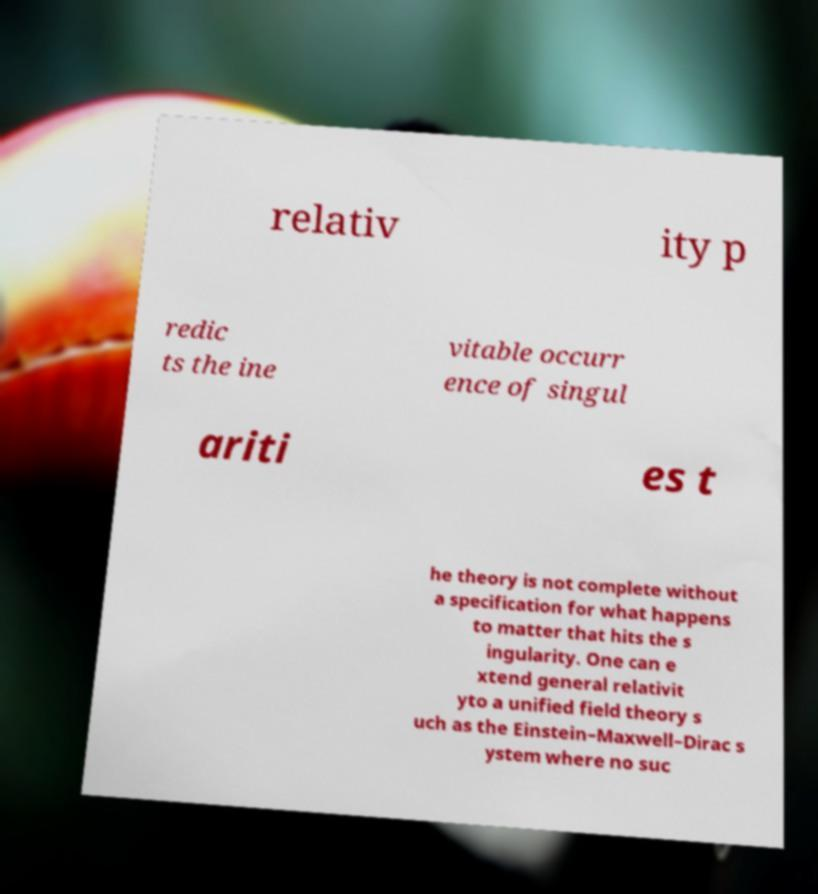Can you read and provide the text displayed in the image?This photo seems to have some interesting text. Can you extract and type it out for me? relativ ity p redic ts the ine vitable occurr ence of singul ariti es t he theory is not complete without a specification for what happens to matter that hits the s ingularity. One can e xtend general relativit yto a unified field theory s uch as the Einstein–Maxwell–Dirac s ystem where no suc 